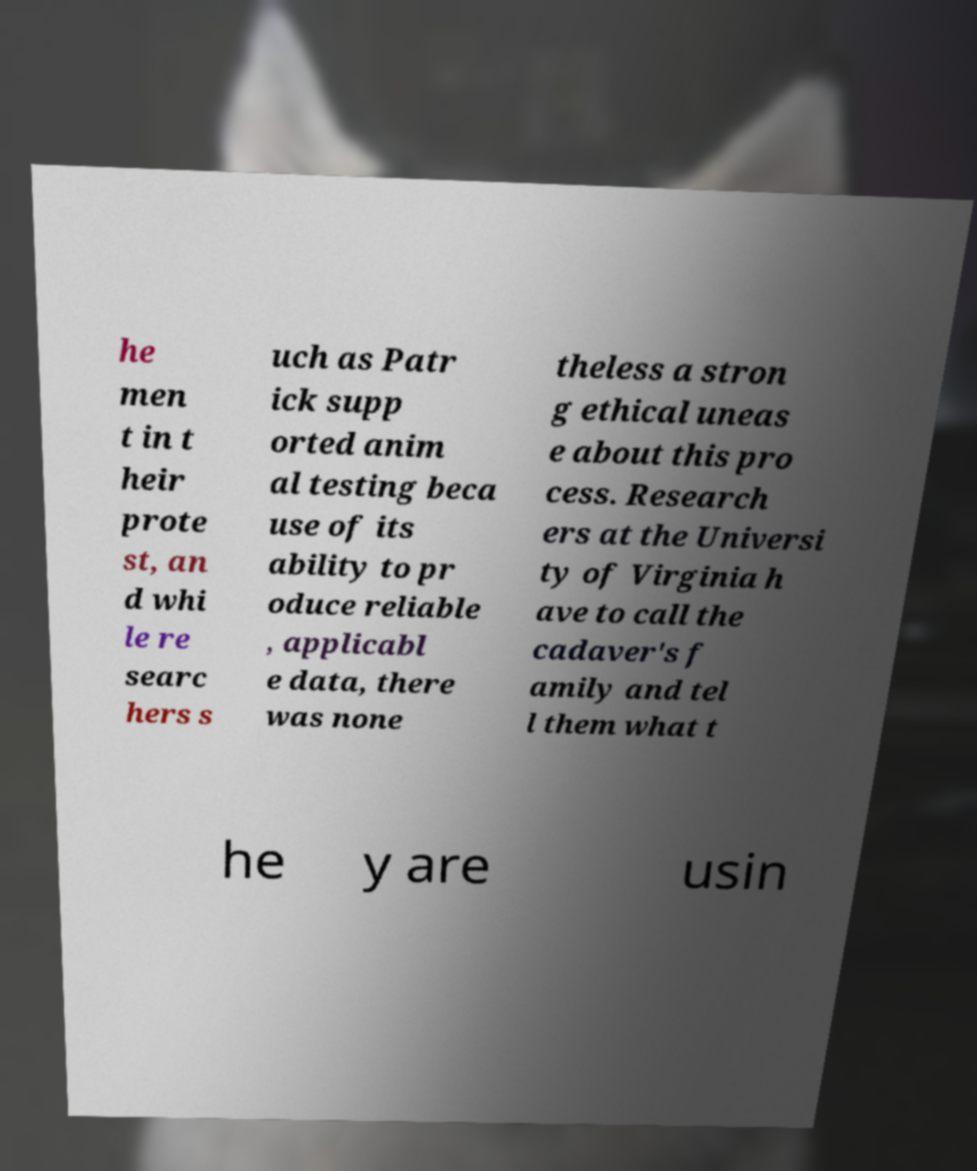Could you extract and type out the text from this image? he men t in t heir prote st, an d whi le re searc hers s uch as Patr ick supp orted anim al testing beca use of its ability to pr oduce reliable , applicabl e data, there was none theless a stron g ethical uneas e about this pro cess. Research ers at the Universi ty of Virginia h ave to call the cadaver's f amily and tel l them what t he y are usin 